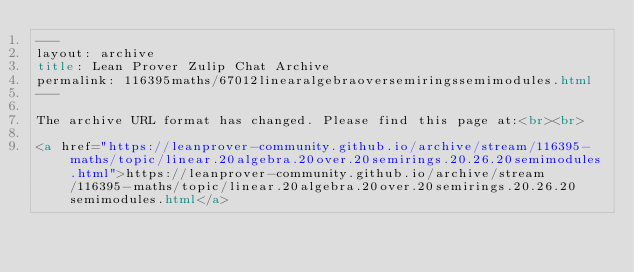<code> <loc_0><loc_0><loc_500><loc_500><_HTML_>---
layout: archive
title: Lean Prover Zulip Chat Archive
permalink: 116395maths/67012linearalgebraoversemiringssemimodules.html
---

The archive URL format has changed. Please find this page at:<br><br>

<a href="https://leanprover-community.github.io/archive/stream/116395-maths/topic/linear.20algebra.20over.20semirings.20.26.20semimodules.html">https://leanprover-community.github.io/archive/stream/116395-maths/topic/linear.20algebra.20over.20semirings.20.26.20semimodules.html</a></code> 